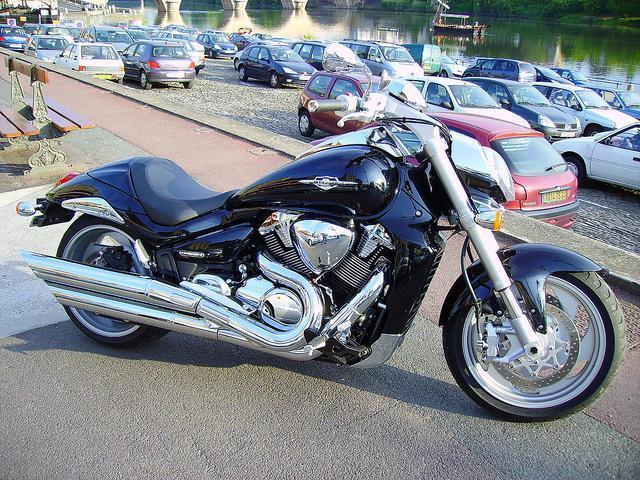How many cars are in the picture?
Give a very brief answer. 11. 